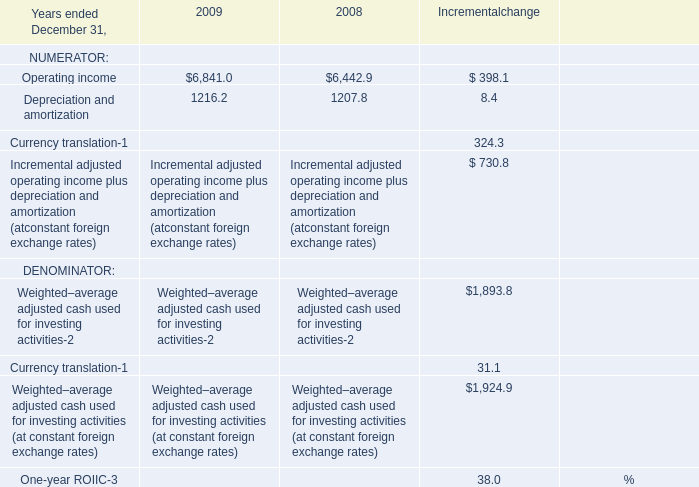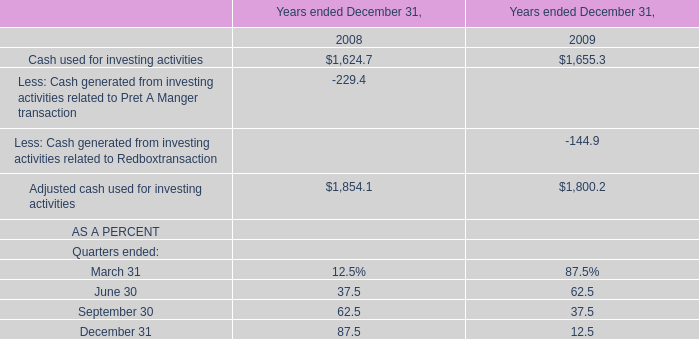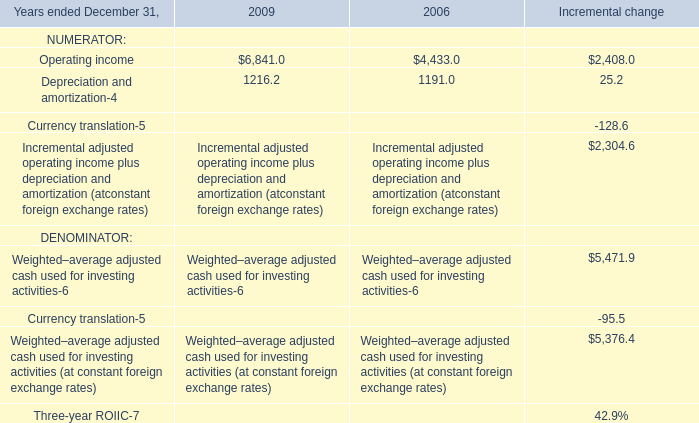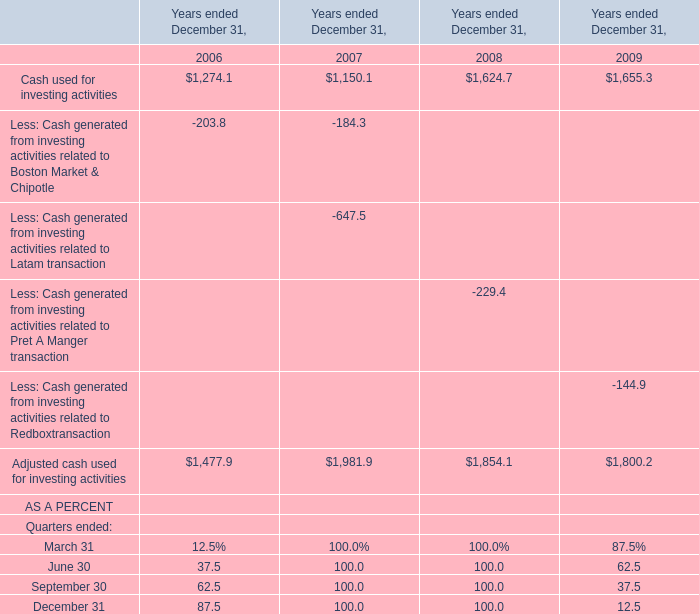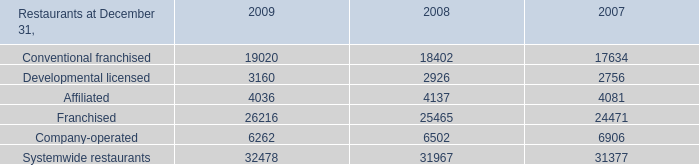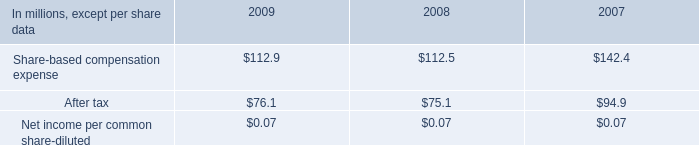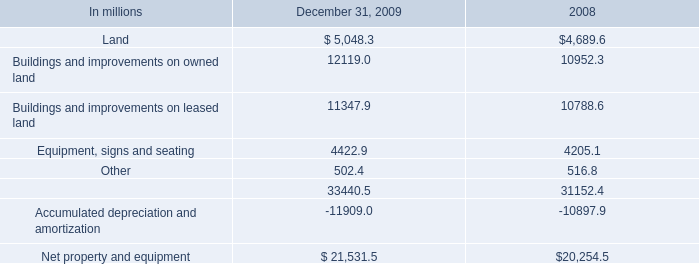What's the current increasing rate of Cash used for investing activities? 
Computations: ((1655.3 - 1624.7) / 1624.7)
Answer: 0.01883. 